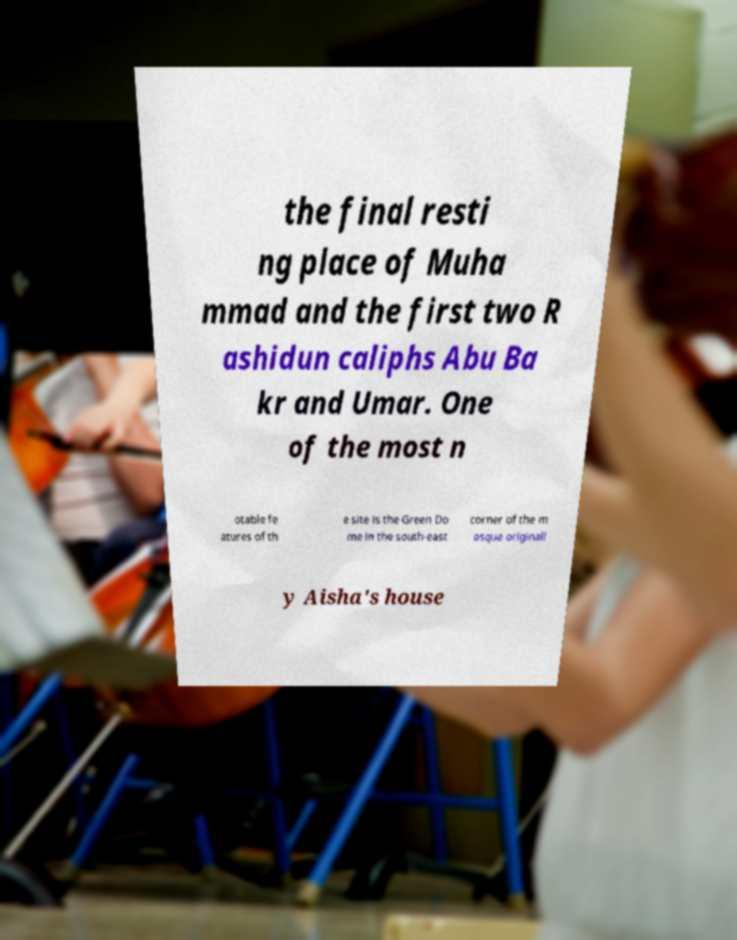Can you accurately transcribe the text from the provided image for me? the final resti ng place of Muha mmad and the first two R ashidun caliphs Abu Ba kr and Umar. One of the most n otable fe atures of th e site is the Green Do me in the south-east corner of the m osque originall y Aisha's house 